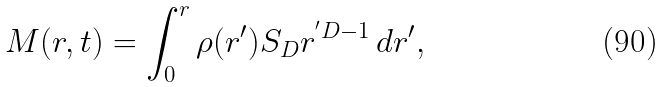Convert formula to latex. <formula><loc_0><loc_0><loc_500><loc_500>M ( r , t ) = \int _ { 0 } ^ { r } \rho ( r ^ { \prime } ) S _ { D } r ^ { ^ { \prime } D - 1 } \, d r ^ { \prime } ,</formula> 